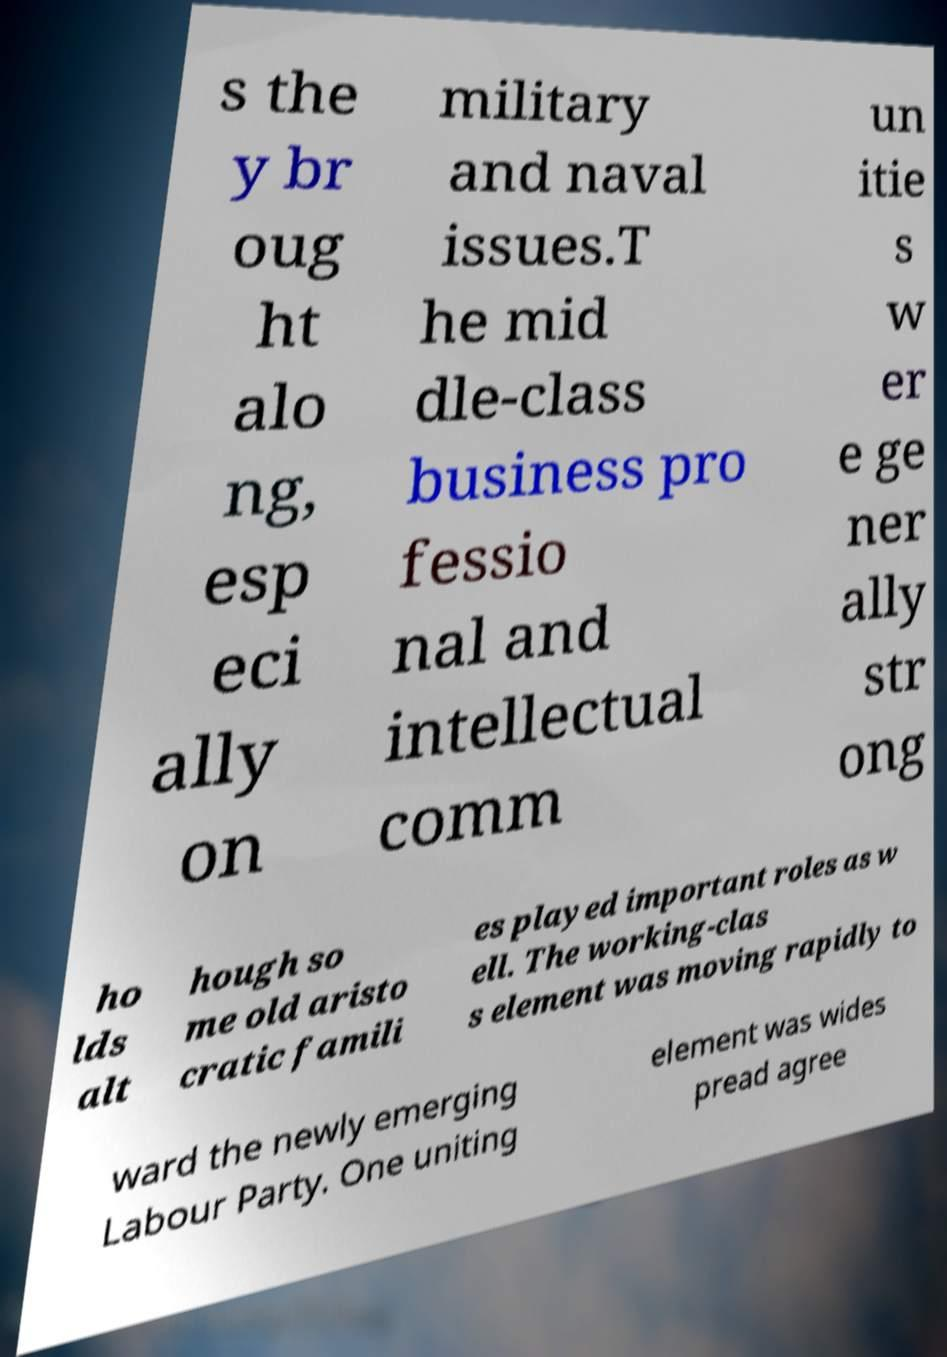Please read and relay the text visible in this image. What does it say? s the y br oug ht alo ng, esp eci ally on military and naval issues.T he mid dle-class business pro fessio nal and intellectual comm un itie s w er e ge ner ally str ong ho lds alt hough so me old aristo cratic famili es played important roles as w ell. The working-clas s element was moving rapidly to ward the newly emerging Labour Party. One uniting element was wides pread agree 